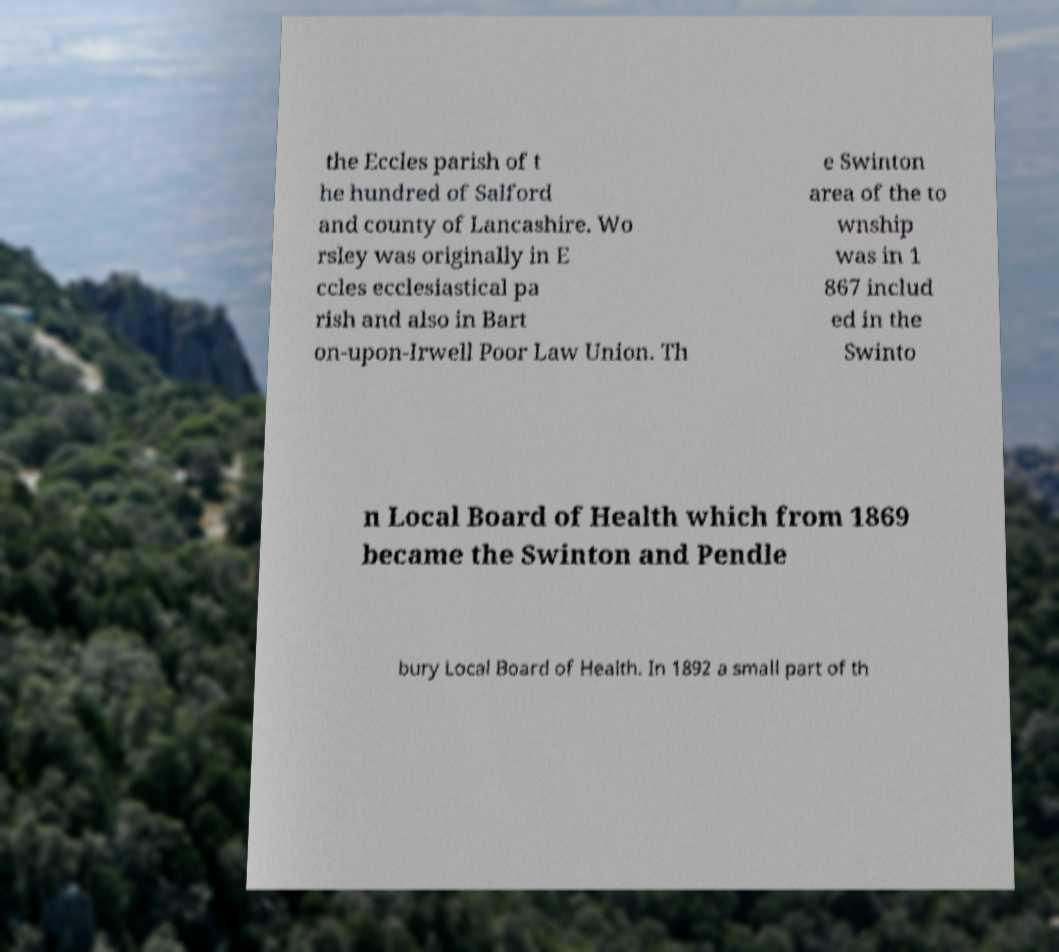I need the written content from this picture converted into text. Can you do that? the Eccles parish of t he hundred of Salford and county of Lancashire. Wo rsley was originally in E ccles ecclesiastical pa rish and also in Bart on-upon-Irwell Poor Law Union. Th e Swinton area of the to wnship was in 1 867 includ ed in the Swinto n Local Board of Health which from 1869 became the Swinton and Pendle bury Local Board of Health. In 1892 a small part of th 